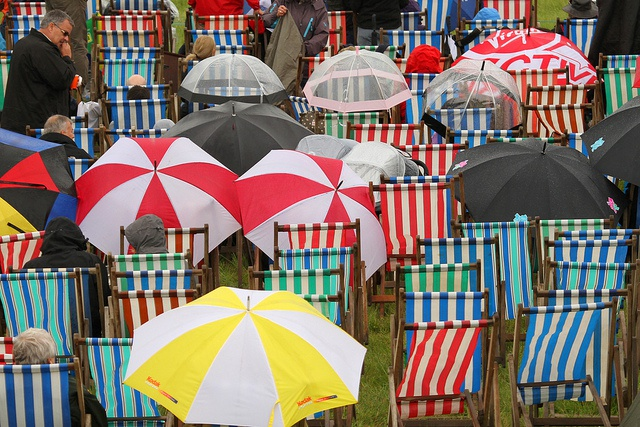Describe the objects in this image and their specific colors. I can see chair in brown, black, maroon, red, and lightgray tones, umbrella in brown, lightgray, gold, and khaki tones, umbrella in brown, lavender, and darkgray tones, chair in brown, teal, darkgray, olive, and black tones, and umbrella in brown, black, and gray tones in this image. 